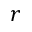Convert formula to latex. <formula><loc_0><loc_0><loc_500><loc_500>r</formula> 